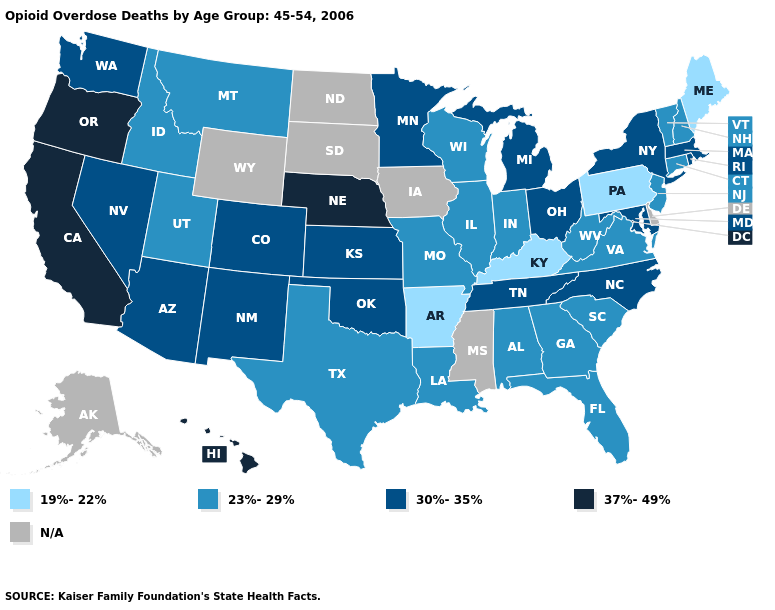Which states hav the highest value in the West?
Keep it brief. California, Hawaii, Oregon. What is the lowest value in the South?
Be succinct. 19%-22%. Name the states that have a value in the range 30%-35%?
Give a very brief answer. Arizona, Colorado, Kansas, Maryland, Massachusetts, Michigan, Minnesota, Nevada, New Mexico, New York, North Carolina, Ohio, Oklahoma, Rhode Island, Tennessee, Washington. Name the states that have a value in the range 23%-29%?
Quick response, please. Alabama, Connecticut, Florida, Georgia, Idaho, Illinois, Indiana, Louisiana, Missouri, Montana, New Hampshire, New Jersey, South Carolina, Texas, Utah, Vermont, Virginia, West Virginia, Wisconsin. Which states have the lowest value in the West?
Quick response, please. Idaho, Montana, Utah. What is the value of Rhode Island?
Keep it brief. 30%-35%. Which states have the highest value in the USA?
Answer briefly. California, Hawaii, Nebraska, Oregon. Name the states that have a value in the range 30%-35%?
Write a very short answer. Arizona, Colorado, Kansas, Maryland, Massachusetts, Michigan, Minnesota, Nevada, New Mexico, New York, North Carolina, Ohio, Oklahoma, Rhode Island, Tennessee, Washington. What is the value of Minnesota?
Be succinct. 30%-35%. Name the states that have a value in the range 37%-49%?
Short answer required. California, Hawaii, Nebraska, Oregon. Name the states that have a value in the range 19%-22%?
Answer briefly. Arkansas, Kentucky, Maine, Pennsylvania. What is the lowest value in the USA?
Answer briefly. 19%-22%. How many symbols are there in the legend?
Write a very short answer. 5. What is the highest value in the USA?
Keep it brief. 37%-49%. 